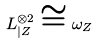<formula> <loc_0><loc_0><loc_500><loc_500>L _ { | Z } ^ { \otimes 2 } \cong \omega _ { Z }</formula> 